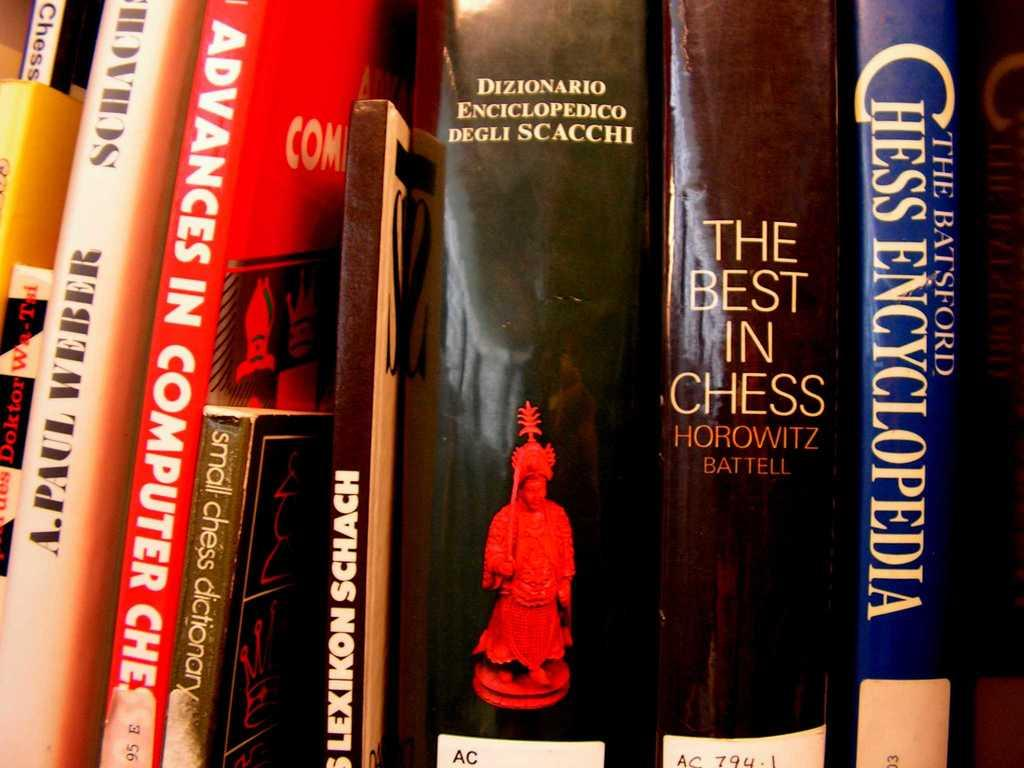<image>
Write a terse but informative summary of the picture. A series of books on chess such as The Chess Encyclopedia sit on a shelf. 